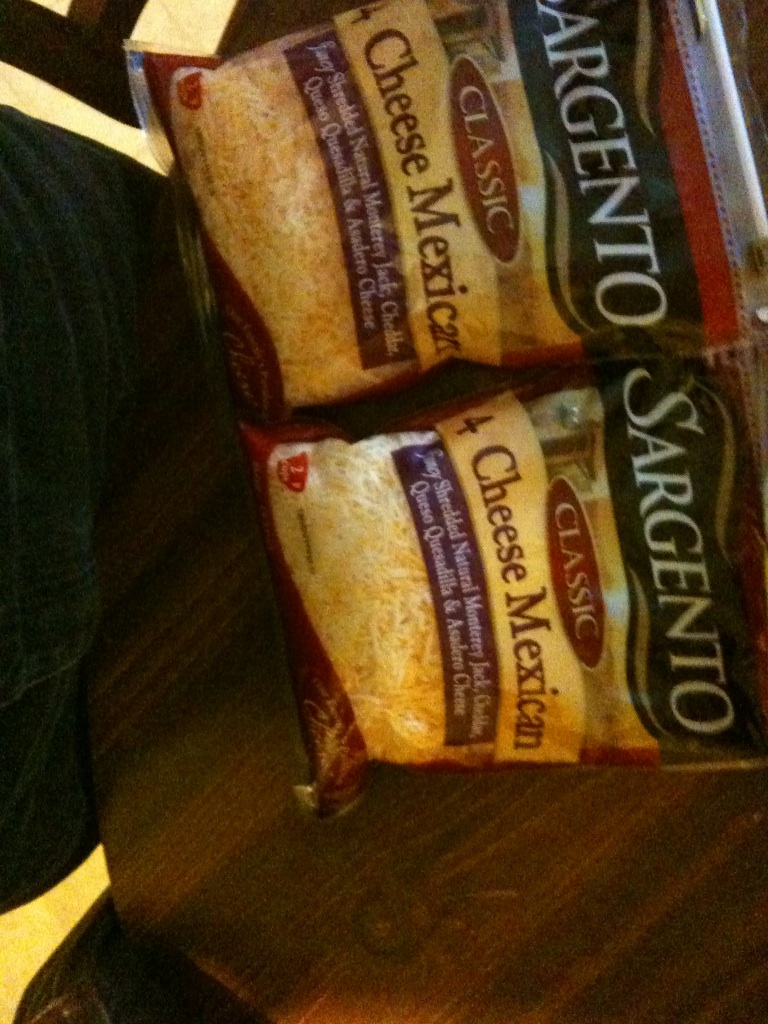Can you suggest some recipes where I can use this 4 Cheese Mexican blend? Certainly! This 4 Cheese Mexican blend is incredibly versatile. Here are some recipes you can try:
1. **Mexican Quesadillas:** Simply fill tortillas with this cheese blend and some sautéed vegetables or chicken, then grill until crispy.
2. **Cheese Tacos:** Add this cheese to your tacos for a melty, delicious layer of flavor.
3. **Enchiladas:** Use it as a filling or topping for your enchiladas.
4. **Cheesy Nachos:** Sprinkle over tortilla chips, add jalapeños, salsa, and bake until the cheese is melted and bubbly.
5. **Mexican Mac and Cheese:** Mix this cheese into your homemade mac and cheese for a Mexican twist.
6. **Stuffed Peppers:** Mix it with rice, beans, and spices, then stuff into bell peppers and bake. What can you tell me about the origin of the cheeses in this blend? The cheeses in this blend – Monterey Jack, Cheddar, Queso Quesadilla, and Asadero – have rich histories:
- **Monterey Jack:** Originated in Monterey, California, it's a mild, semi-hard cheese that was first made by Mexican Franciscan friars.
- **Cheddar:** From the English village of Cheddar in Somerset, this hard cheese is known for its sharp flavor.
- **Queso Quesadilla:** A traditional Mexican cheese known for its melting properties, commonly used in quesadillas.
- **Asadero:** Also known as 'Oaxaca cheese,' it hails from the Oaxaca region in Mexico, famous for its excellent melting abilities and mild, creamy flavor. If these cheeses were characters in a story, how would you describe their personalities? Imagine a little town called Cheesetown where our cheese characters live:
- **Monterey Jack:** Calm and laid-back, he's the easygoing guy everyone likes. Always ready to help and very versatile.
- **Cheddar:** Bold and confident, Cheddar is the leader with a sharp mind and a penchant for taking charge of situations.
- **Queso Quesadilla:** Friendly and warm, always making sure everyone feels at ease. Known for bringing people together.
- **Asadero:** The artist of the group, Asadero is smooth and creative, always coming up with new ideas to delight friends. 